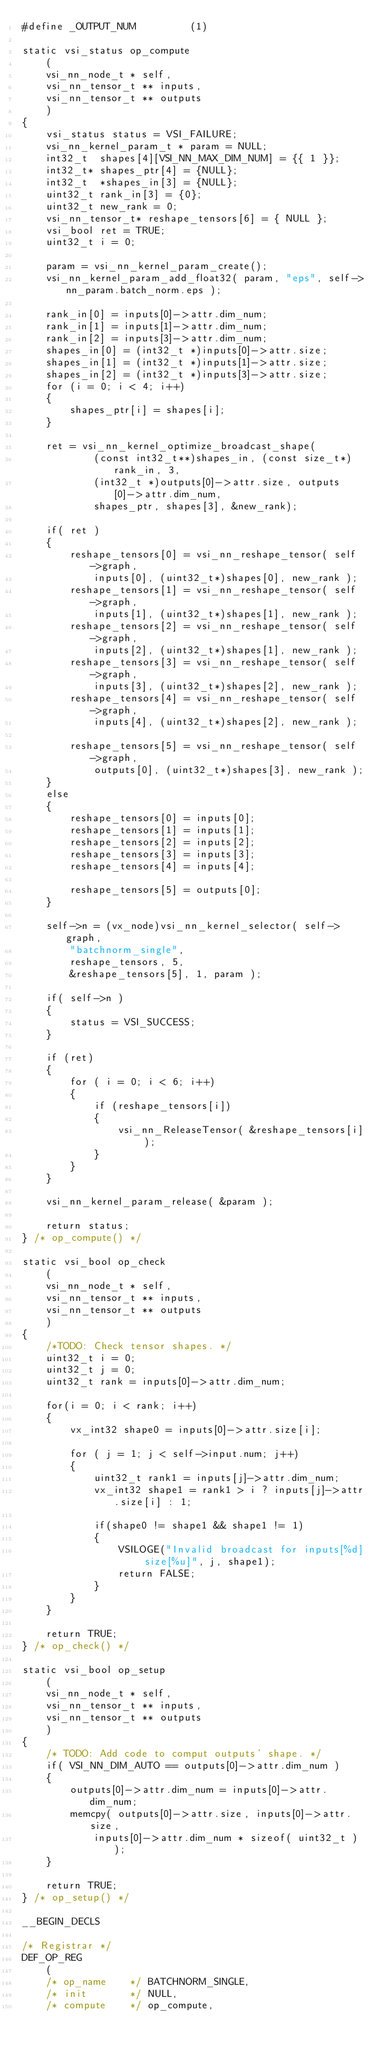<code> <loc_0><loc_0><loc_500><loc_500><_C_>#define _OUTPUT_NUM         (1)

static vsi_status op_compute
    (
    vsi_nn_node_t * self,
    vsi_nn_tensor_t ** inputs,
    vsi_nn_tensor_t ** outputs
    )
{
    vsi_status status = VSI_FAILURE;
    vsi_nn_kernel_param_t * param = NULL;
    int32_t  shapes[4][VSI_NN_MAX_DIM_NUM] = {{ 1 }};
    int32_t* shapes_ptr[4] = {NULL};
    int32_t  *shapes_in[3] = {NULL};
    uint32_t rank_in[3] = {0};
    uint32_t new_rank = 0;
    vsi_nn_tensor_t* reshape_tensors[6] = { NULL };
    vsi_bool ret = TRUE;
    uint32_t i = 0;

    param = vsi_nn_kernel_param_create();
    vsi_nn_kernel_param_add_float32( param, "eps", self->nn_param.batch_norm.eps );

    rank_in[0] = inputs[0]->attr.dim_num;
    rank_in[1] = inputs[1]->attr.dim_num;
    rank_in[2] = inputs[3]->attr.dim_num;
    shapes_in[0] = (int32_t *)inputs[0]->attr.size;
    shapes_in[1] = (int32_t *)inputs[1]->attr.size;
    shapes_in[2] = (int32_t *)inputs[3]->attr.size;
    for (i = 0; i < 4; i++)
    {
        shapes_ptr[i] = shapes[i];
    }

    ret = vsi_nn_kernel_optimize_broadcast_shape(
            (const int32_t**)shapes_in, (const size_t*)rank_in, 3,
            (int32_t *)outputs[0]->attr.size, outputs[0]->attr.dim_num,
            shapes_ptr, shapes[3], &new_rank);

    if( ret )
    {
        reshape_tensors[0] = vsi_nn_reshape_tensor( self->graph,
            inputs[0], (uint32_t*)shapes[0], new_rank );
        reshape_tensors[1] = vsi_nn_reshape_tensor( self->graph,
            inputs[1], (uint32_t*)shapes[1], new_rank );
        reshape_tensors[2] = vsi_nn_reshape_tensor( self->graph,
            inputs[2], (uint32_t*)shapes[1], new_rank );
        reshape_tensors[3] = vsi_nn_reshape_tensor( self->graph,
            inputs[3], (uint32_t*)shapes[2], new_rank );
        reshape_tensors[4] = vsi_nn_reshape_tensor( self->graph,
            inputs[4], (uint32_t*)shapes[2], new_rank );

        reshape_tensors[5] = vsi_nn_reshape_tensor( self->graph,
            outputs[0], (uint32_t*)shapes[3], new_rank );
    }
    else
    {
        reshape_tensors[0] = inputs[0];
        reshape_tensors[1] = inputs[1];
        reshape_tensors[2] = inputs[2];
        reshape_tensors[3] = inputs[3];
        reshape_tensors[4] = inputs[4];

        reshape_tensors[5] = outputs[0];
    }

    self->n = (vx_node)vsi_nn_kernel_selector( self->graph,
        "batchnorm_single",
        reshape_tensors, 5,
        &reshape_tensors[5], 1, param );

    if( self->n )
    {
        status = VSI_SUCCESS;
    }

    if (ret)
    {
        for ( i = 0; i < 6; i++)
        {
            if (reshape_tensors[i])
            {
                vsi_nn_ReleaseTensor( &reshape_tensors[i] );
            }
        }
    }

    vsi_nn_kernel_param_release( &param );

    return status;
} /* op_compute() */

static vsi_bool op_check
    (
    vsi_nn_node_t * self,
    vsi_nn_tensor_t ** inputs,
    vsi_nn_tensor_t ** outputs
    )
{
    /*TODO: Check tensor shapes. */
    uint32_t i = 0;
    uint32_t j = 0;
    uint32_t rank = inputs[0]->attr.dim_num;

    for(i = 0; i < rank; i++)
    {
        vx_int32 shape0 = inputs[0]->attr.size[i];

        for ( j = 1; j < self->input.num; j++)
        {
            uint32_t rank1 = inputs[j]->attr.dim_num;
            vx_int32 shape1 = rank1 > i ? inputs[j]->attr.size[i] : 1;

            if(shape0 != shape1 && shape1 != 1)
            {
                VSILOGE("Invalid broadcast for inputs[%d] size[%u]", j, shape1);
                return FALSE;
            }
        }
    }

    return TRUE;
} /* op_check() */

static vsi_bool op_setup
    (
    vsi_nn_node_t * self,
    vsi_nn_tensor_t ** inputs,
    vsi_nn_tensor_t ** outputs
    )
{
    /* TODO: Add code to comput outputs' shape. */
    if( VSI_NN_DIM_AUTO == outputs[0]->attr.dim_num )
    {
        outputs[0]->attr.dim_num = inputs[0]->attr.dim_num;
        memcpy( outputs[0]->attr.size, inputs[0]->attr.size,
            inputs[0]->attr.dim_num * sizeof( uint32_t ) );
    }

    return TRUE;
} /* op_setup() */

__BEGIN_DECLS

/* Registrar */
DEF_OP_REG
    (
    /* op_name    */ BATCHNORM_SINGLE,
    /* init       */ NULL,
    /* compute    */ op_compute,</code> 